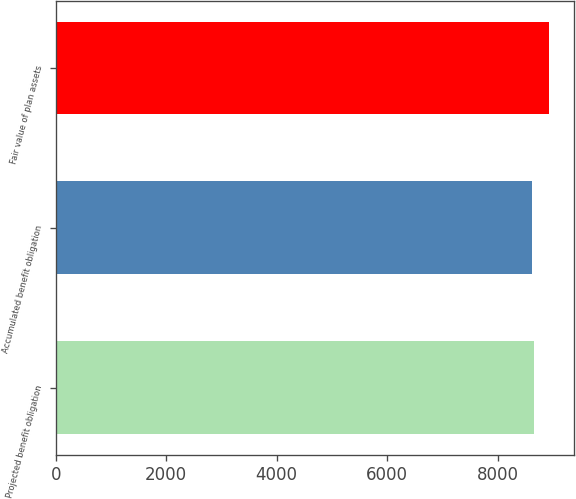Convert chart to OTSL. <chart><loc_0><loc_0><loc_500><loc_500><bar_chart><fcel>Projected benefit obligation<fcel>Accumulated benefit obligation<fcel>Fair value of plan assets<nl><fcel>8655.2<fcel>8624<fcel>8936<nl></chart> 